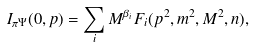Convert formula to latex. <formula><loc_0><loc_0><loc_500><loc_500>I _ { \pi \Psi } ( 0 , p ) = \sum _ { i } M ^ { \beta _ { i } } F _ { i } ( p ^ { 2 } , m ^ { 2 } , M ^ { 2 } , n ) ,</formula> 